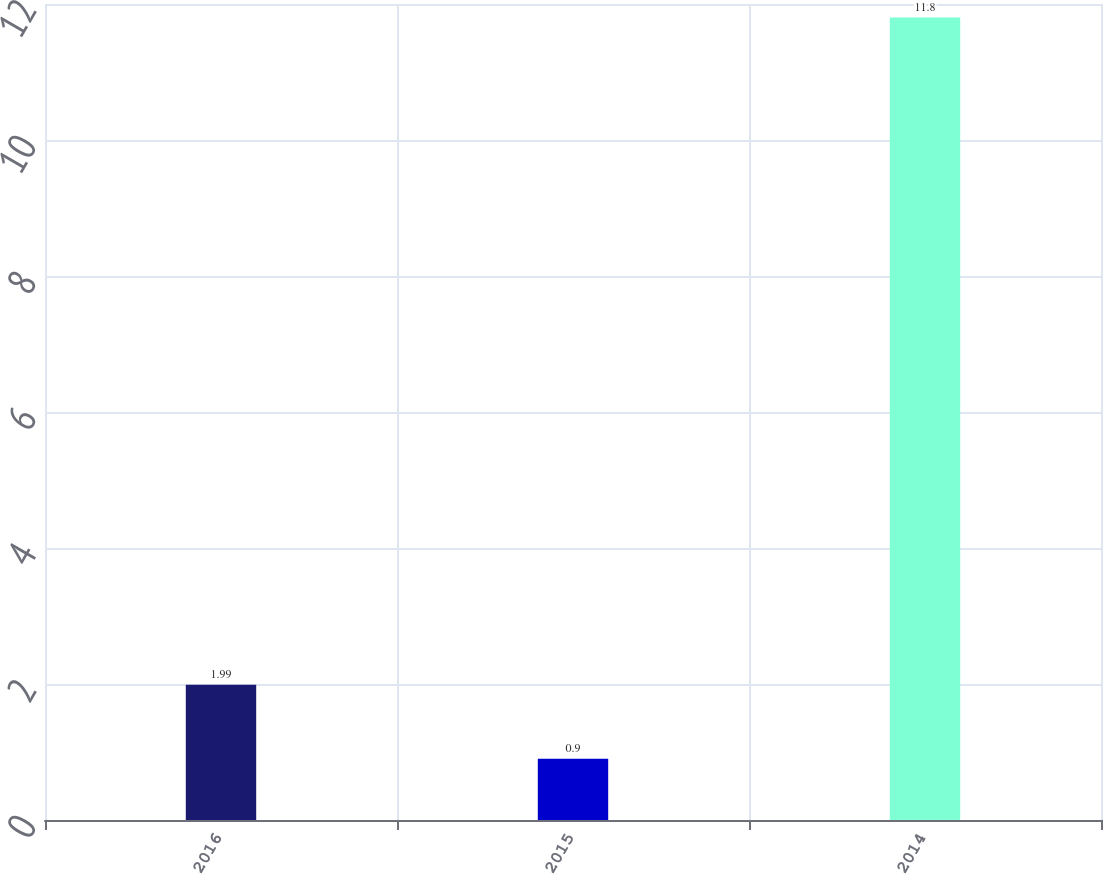Convert chart to OTSL. <chart><loc_0><loc_0><loc_500><loc_500><bar_chart><fcel>2016<fcel>2015<fcel>2014<nl><fcel>1.99<fcel>0.9<fcel>11.8<nl></chart> 